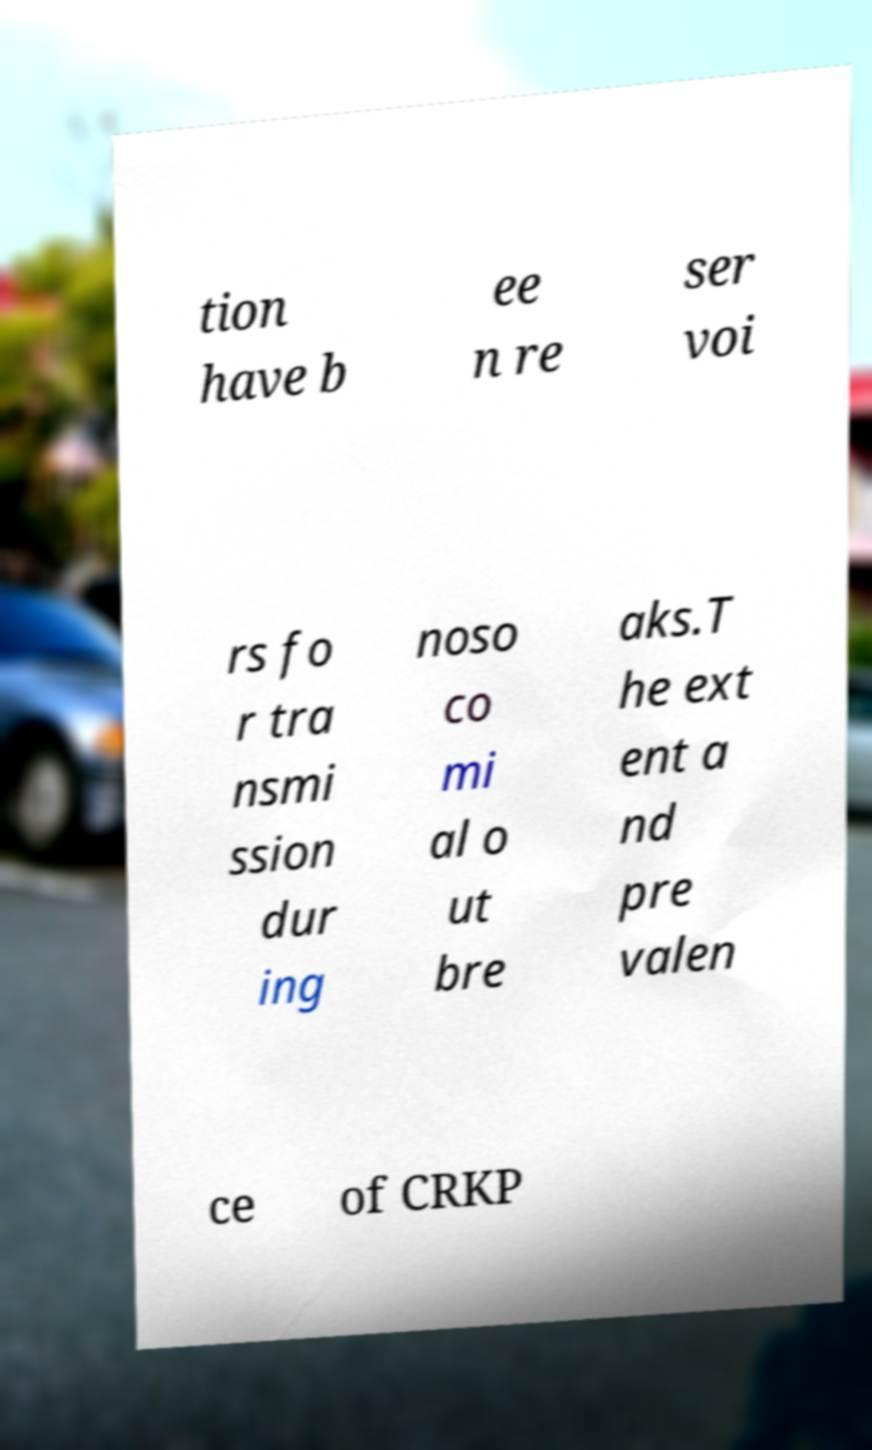Can you read and provide the text displayed in the image?This photo seems to have some interesting text. Can you extract and type it out for me? tion have b ee n re ser voi rs fo r tra nsmi ssion dur ing noso co mi al o ut bre aks.T he ext ent a nd pre valen ce of CRKP 